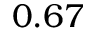<formula> <loc_0><loc_0><loc_500><loc_500>0 . 6 7</formula> 